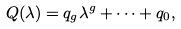<formula> <loc_0><loc_0><loc_500><loc_500>Q ( \lambda ) = q _ { g } \lambda ^ { g } + \cdots + q _ { 0 } ,</formula> 